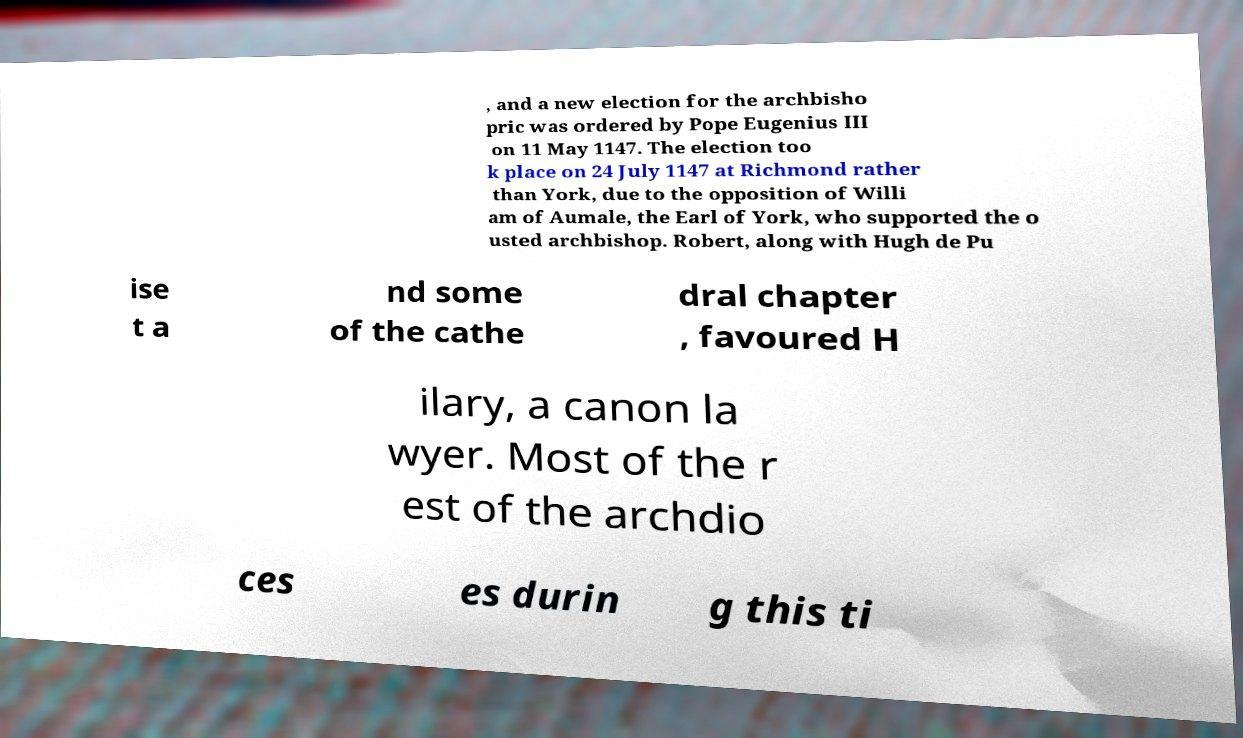Please identify and transcribe the text found in this image. , and a new election for the archbisho pric was ordered by Pope Eugenius III on 11 May 1147. The election too k place on 24 July 1147 at Richmond rather than York, due to the opposition of Willi am of Aumale, the Earl of York, who supported the o usted archbishop. Robert, along with Hugh de Pu ise t a nd some of the cathe dral chapter , favoured H ilary, a canon la wyer. Most of the r est of the archdio ces es durin g this ti 